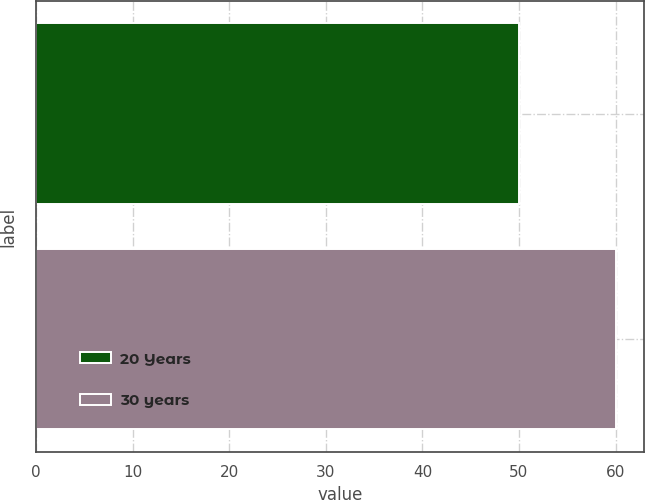Convert chart. <chart><loc_0><loc_0><loc_500><loc_500><bar_chart><fcel>20 Years<fcel>30 years<nl><fcel>50<fcel>60<nl></chart> 